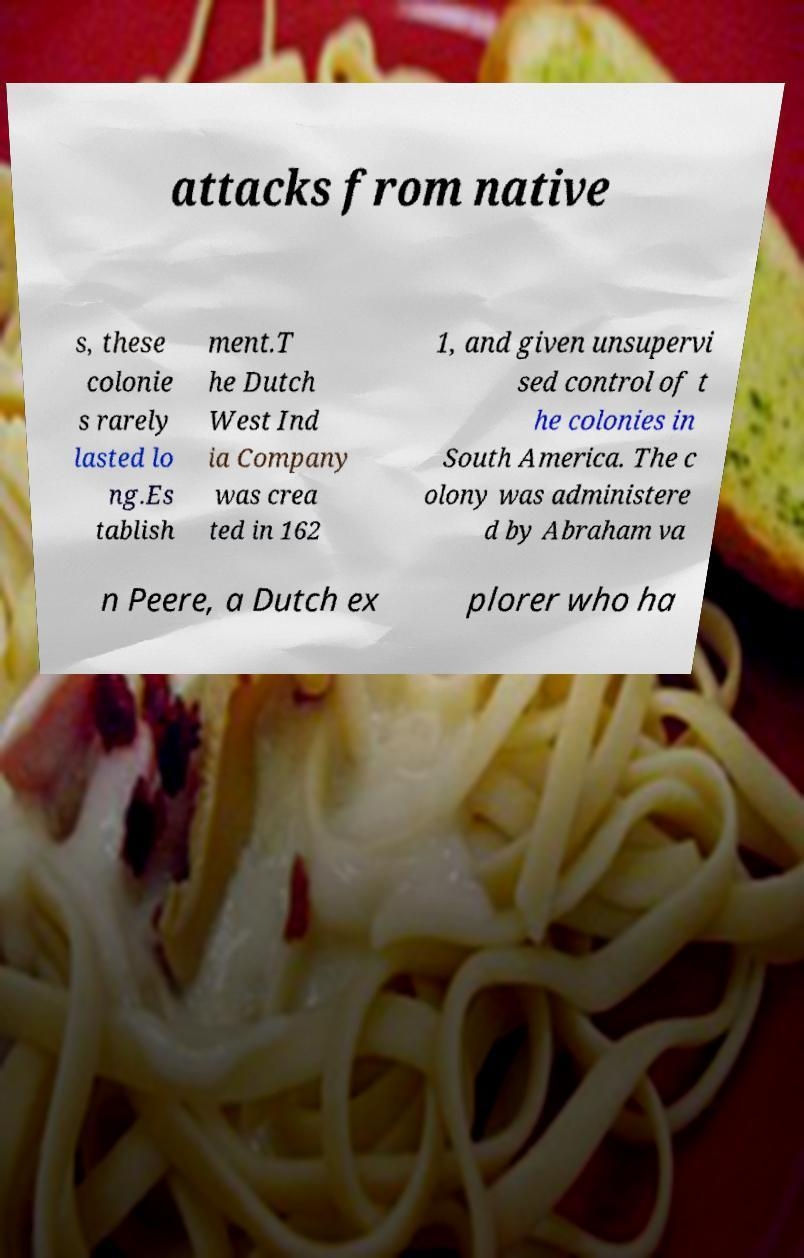Can you read and provide the text displayed in the image?This photo seems to have some interesting text. Can you extract and type it out for me? attacks from native s, these colonie s rarely lasted lo ng.Es tablish ment.T he Dutch West Ind ia Company was crea ted in 162 1, and given unsupervi sed control of t he colonies in South America. The c olony was administere d by Abraham va n Peere, a Dutch ex plorer who ha 